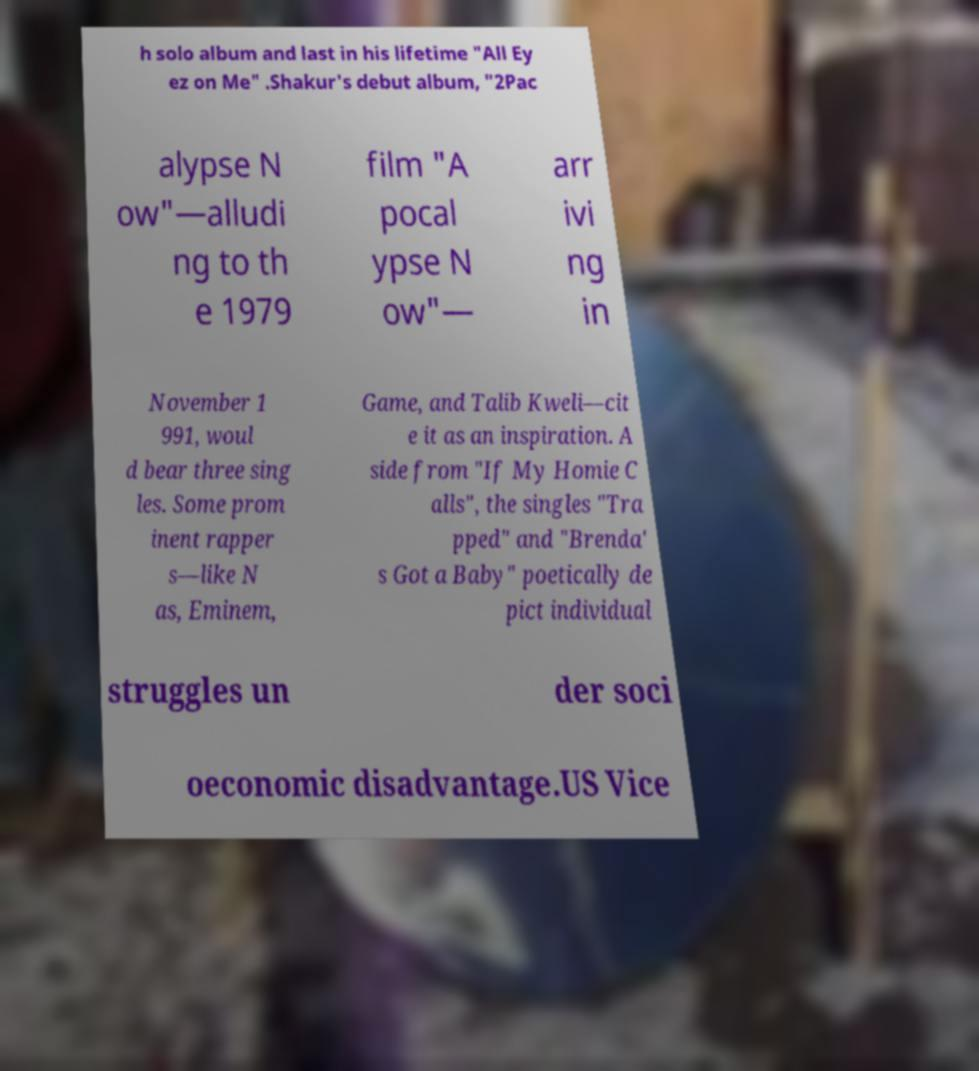There's text embedded in this image that I need extracted. Can you transcribe it verbatim? h solo album and last in his lifetime "All Ey ez on Me" .Shakur's debut album, "2Pac alypse N ow"—alludi ng to th e 1979 film "A pocal ypse N ow"— arr ivi ng in November 1 991, woul d bear three sing les. Some prom inent rapper s—like N as, Eminem, Game, and Talib Kweli—cit e it as an inspiration. A side from "If My Homie C alls", the singles "Tra pped" and "Brenda' s Got a Baby" poetically de pict individual struggles un der soci oeconomic disadvantage.US Vice 